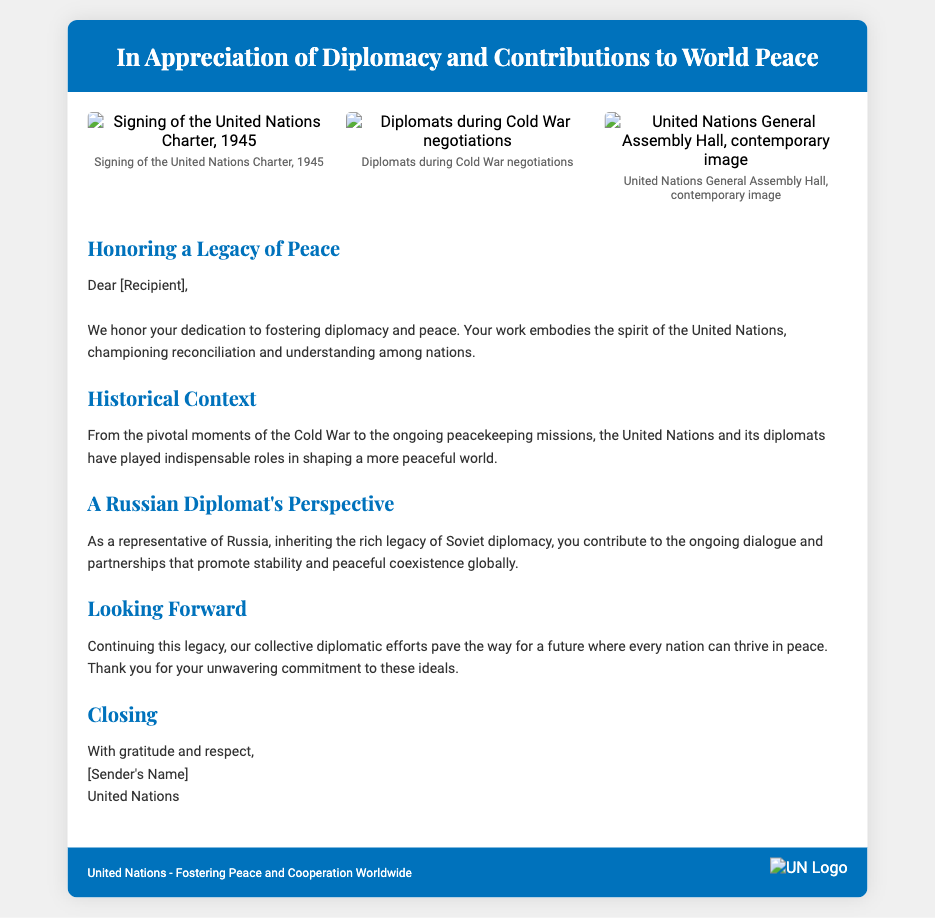What is the title of the card? The title is prominently displayed in the header section of the document.
Answer: In Appreciation of Diplomacy and Contributions to World Peace What year was the United Nations Charter signed? The document features an image of the signing event with its corresponding caption.
Answer: 1945 What is the color of the header? The header background color is specified in the style of the document.
Answer: Blue Which organization is sending this appreciation card? The footer section mentions the organization responsible for the card.
Answer: United Nations What is the primary theme conveyed in the card? The text sections collectively highlight the focus of the card.
Answer: Peace How many images are included in the image gallery? The layout specifies the number of image containers shown.
Answer: Three What aspect of diplomacy does the card specifically mention from the Russian perspective? This detail is found in the text section that discusses the Russian diplomat's role.
Answer: Stability What is stated as the future goal of diplomatic efforts? The closing section of the text outlines the aspirations for the future.
Answer: Peace Who is the card addressed to? The salutation area of the card leaves space for personalization.
Answer: [Recipient] 